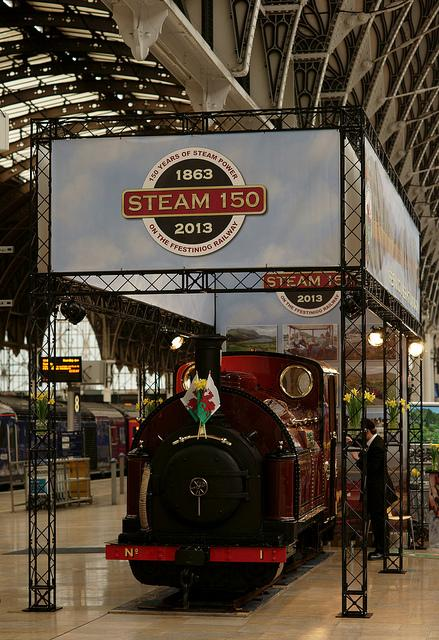Which anniversary is being celebrated? Please explain your reasoning. 150. There are 150 years between 1863 and 2013 as commemorated on the sign. 